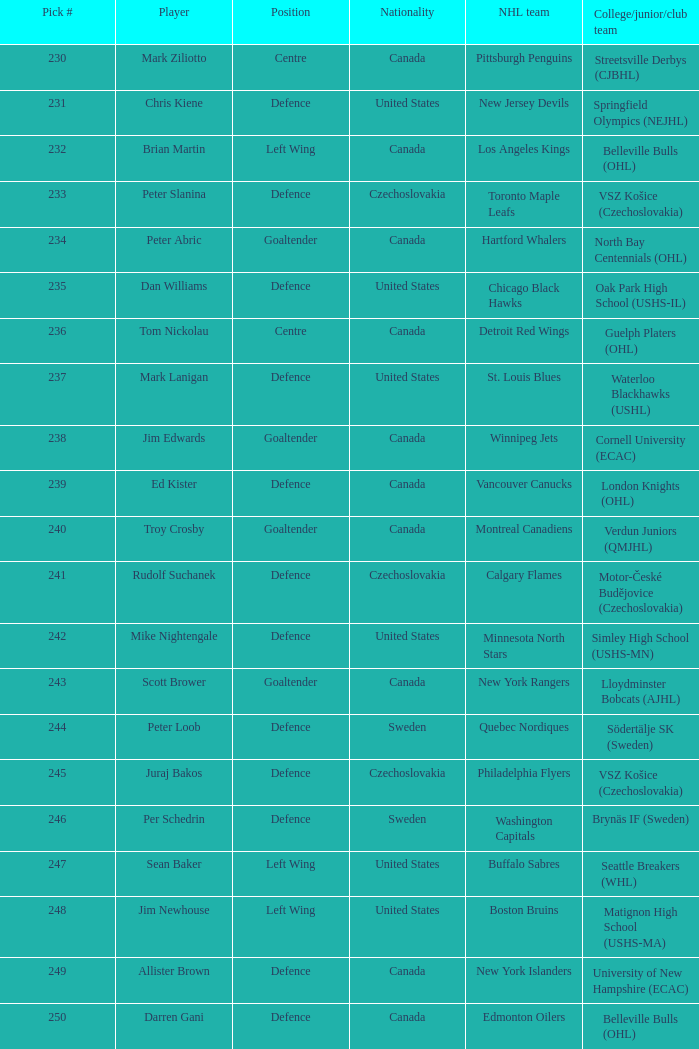Can you provide the names of the players on brynäs if team in sweden? Per Schedrin. 